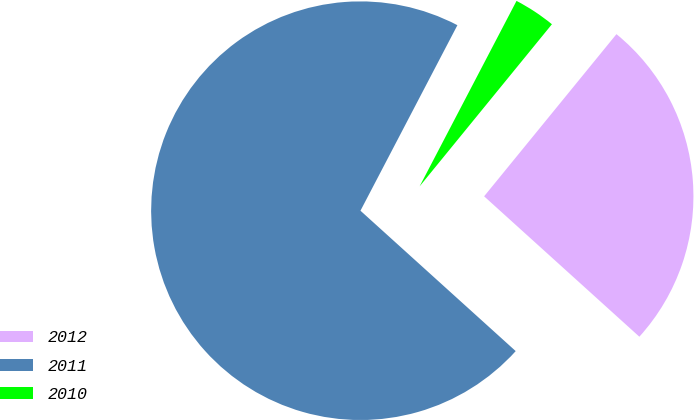Convert chart. <chart><loc_0><loc_0><loc_500><loc_500><pie_chart><fcel>2012<fcel>2011<fcel>2010<nl><fcel>25.81%<fcel>70.97%<fcel>3.23%<nl></chart> 